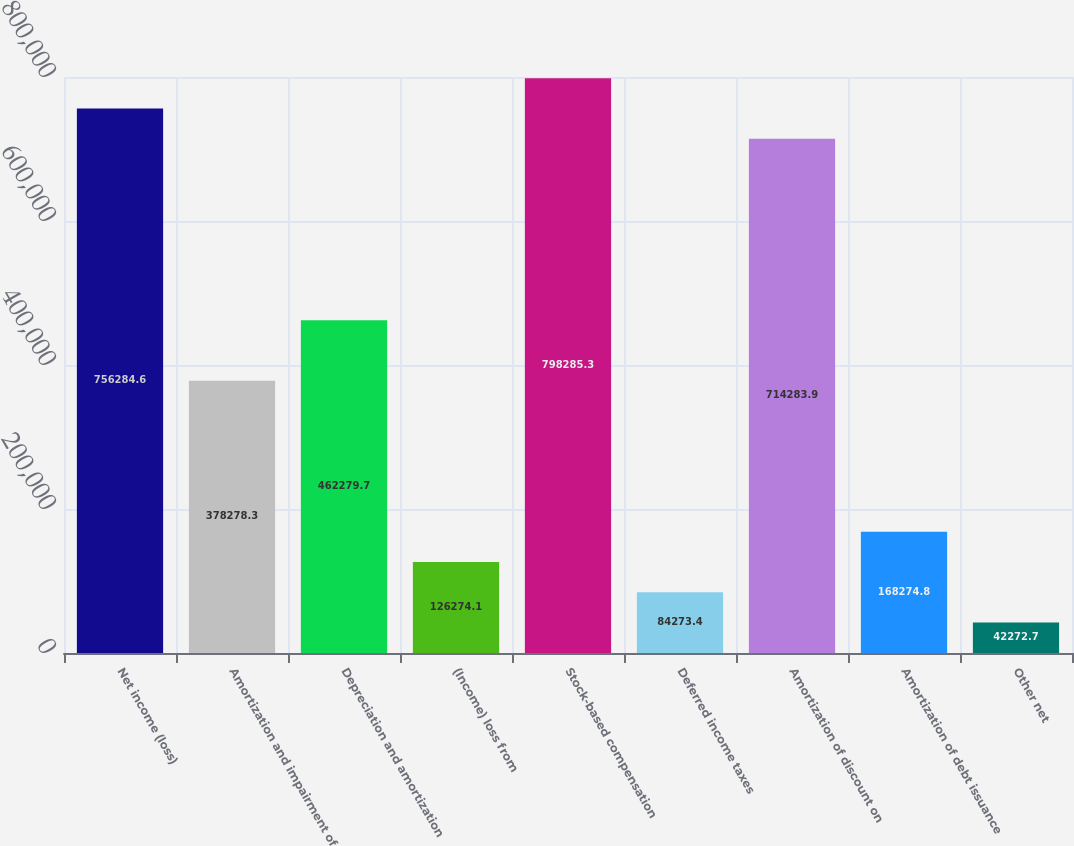Convert chart. <chart><loc_0><loc_0><loc_500><loc_500><bar_chart><fcel>Net income (loss)<fcel>Amortization and impairment of<fcel>Depreciation and amortization<fcel>(Income) loss from<fcel>Stock-based compensation<fcel>Deferred income taxes<fcel>Amortization of discount on<fcel>Amortization of debt issuance<fcel>Other net<nl><fcel>756285<fcel>378278<fcel>462280<fcel>126274<fcel>798285<fcel>84273.4<fcel>714284<fcel>168275<fcel>42272.7<nl></chart> 